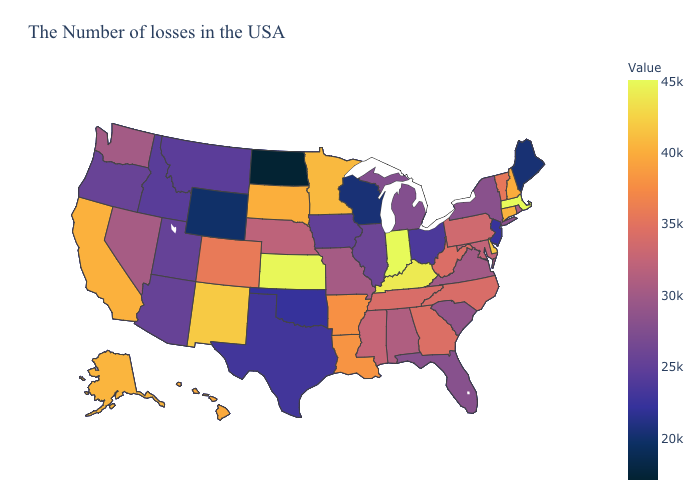Does Nebraska have a lower value than California?
Give a very brief answer. Yes. Is the legend a continuous bar?
Concise answer only. Yes. Does Louisiana have a lower value than Massachusetts?
Write a very short answer. Yes. 